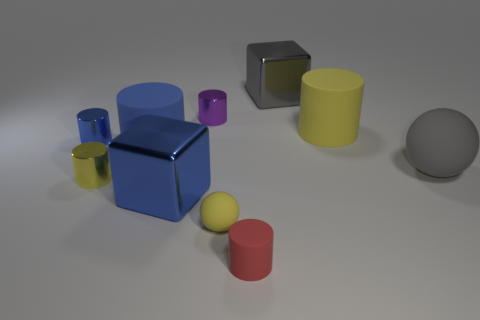Subtract all big cylinders. How many cylinders are left? 4 Subtract all blue cylinders. How many cylinders are left? 4 Subtract 2 cylinders. How many cylinders are left? 4 Subtract all purple cylinders. Subtract all blue spheres. How many cylinders are left? 5 Subtract all cylinders. How many objects are left? 4 Add 3 large cylinders. How many large cylinders are left? 5 Add 3 small red rubber cylinders. How many small red rubber cylinders exist? 4 Subtract 0 brown blocks. How many objects are left? 10 Subtract all red rubber cylinders. Subtract all metallic blocks. How many objects are left? 7 